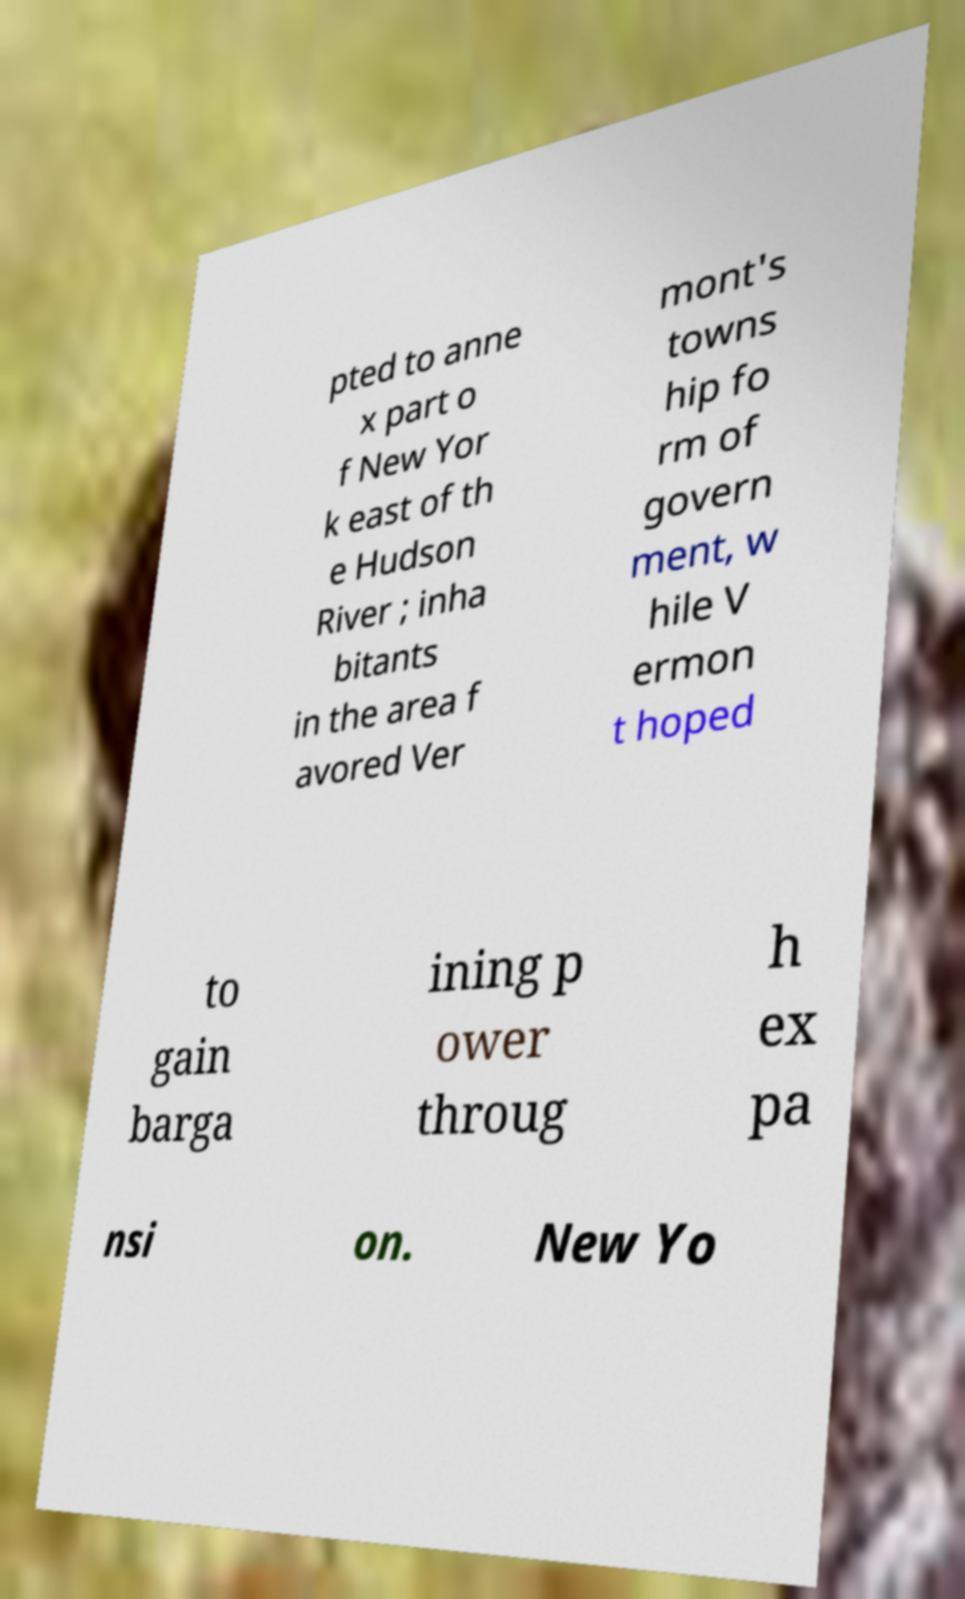Please identify and transcribe the text found in this image. pted to anne x part o f New Yor k east of th e Hudson River ; inha bitants in the area f avored Ver mont's towns hip fo rm of govern ment, w hile V ermon t hoped to gain barga ining p ower throug h ex pa nsi on. New Yo 